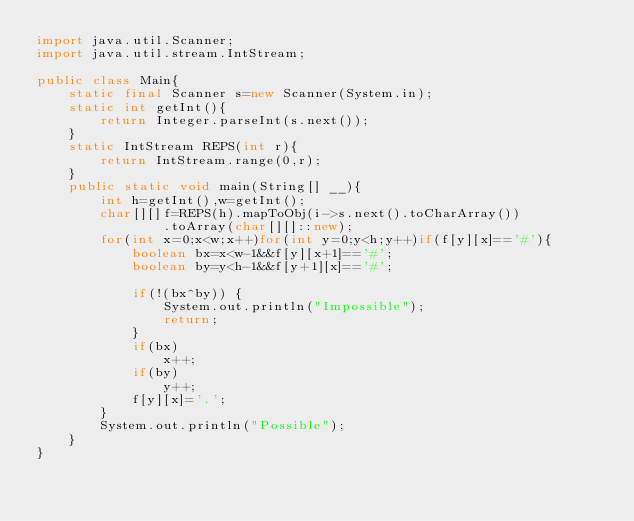<code> <loc_0><loc_0><loc_500><loc_500><_Java_>import java.util.Scanner;
import java.util.stream.IntStream;
 
public class Main{
	static final Scanner s=new Scanner(System.in);
	static int getInt(){
		return Integer.parseInt(s.next());
	}
	static IntStream REPS(int r){
		return IntStream.range(0,r);
	}
	public static void main(String[] __){
		int h=getInt(),w=getInt();
		char[][]f=REPS(h).mapToObj(i->s.next().toCharArray())
				.toArray(char[][]::new);
		for(int x=0;x<w;x++)for(int y=0;y<h;y++)if(f[y][x]=='#'){
			boolean bx=x<w-1&&f[y][x+1]=='#';
			boolean by=y<h-1&&f[y+1][x]=='#';
			
			if(!(bx^by)) {
				System.out.println("Impossible");
				return;
			}
			if(bx)
				x++;
			if(by)
				y++;
			f[y][x]='.';
		}
		System.out.println("Possible");
	}
}</code> 